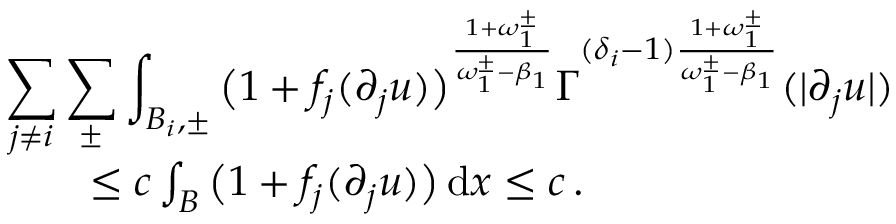Convert formula to latex. <formula><loc_0><loc_0><loc_500><loc_500>\begin{array} { r l r } { { \sum _ { j \not = i } \sum _ { \pm } \int _ { B _ { i } , \pm } \left ( 1 + f _ { j } ( \partial _ { j } u ) \right ) ^ { \frac { 1 + \omega _ { 1 } ^ { \pm } } { \omega _ { 1 } ^ { \pm } - \beta _ { 1 } } } \Gamma ^ { ( \delta _ { i } - 1 ) \frac { 1 + \omega _ { 1 } ^ { \pm } } { \omega _ { 1 } ^ { \pm } - \beta _ { 1 } } } ( | \partial _ { j } u | ) } } \\ & { \leq c \int _ { B } \left ( 1 + f _ { j } ( \partial _ { j } u ) \right ) \, d x \leq c \, . } \end{array}</formula> 